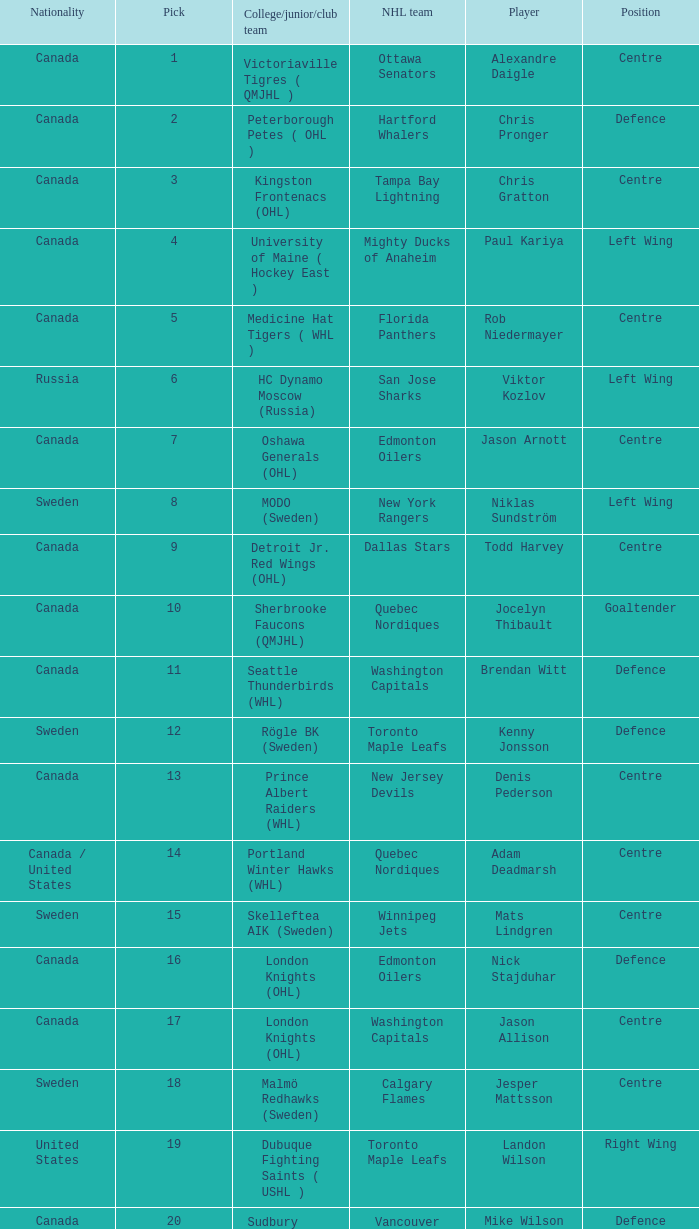What is the college/junior/club team name of player Mats Lindgren? Skelleftea AIK (Sweden). 